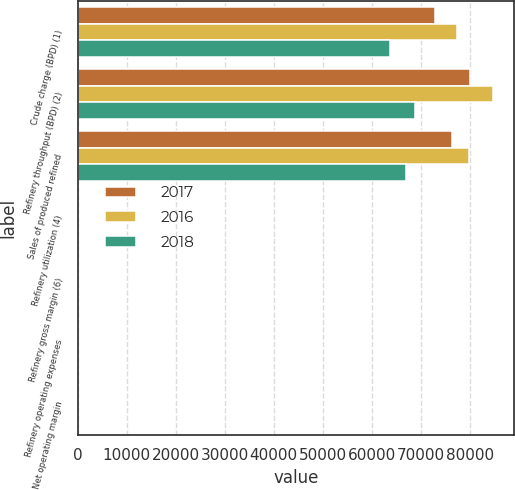Convert chart. <chart><loc_0><loc_0><loc_500><loc_500><stacked_bar_chart><ecel><fcel>Crude charge (BPD) (1)<fcel>Refinery throughput (BPD) (2)<fcel>Sales of produced refined<fcel>Refinery utilization (4)<fcel>Refinery gross margin (6)<fcel>Refinery operating expenses<fcel>Net operating margin<nl><fcel>2017<fcel>72890<fcel>79980<fcel>76300<fcel>75.1<fcel>26.55<fcel>11.28<fcel>14.72<nl><fcel>2016<fcel>77380<fcel>84790<fcel>79840<fcel>79.8<fcel>15.78<fcel>9.85<fcel>5.32<nl><fcel>2018<fcel>63650<fcel>68870<fcel>66950<fcel>65.6<fcel>8.8<fcel>9.89<fcel>1.37<nl></chart> 